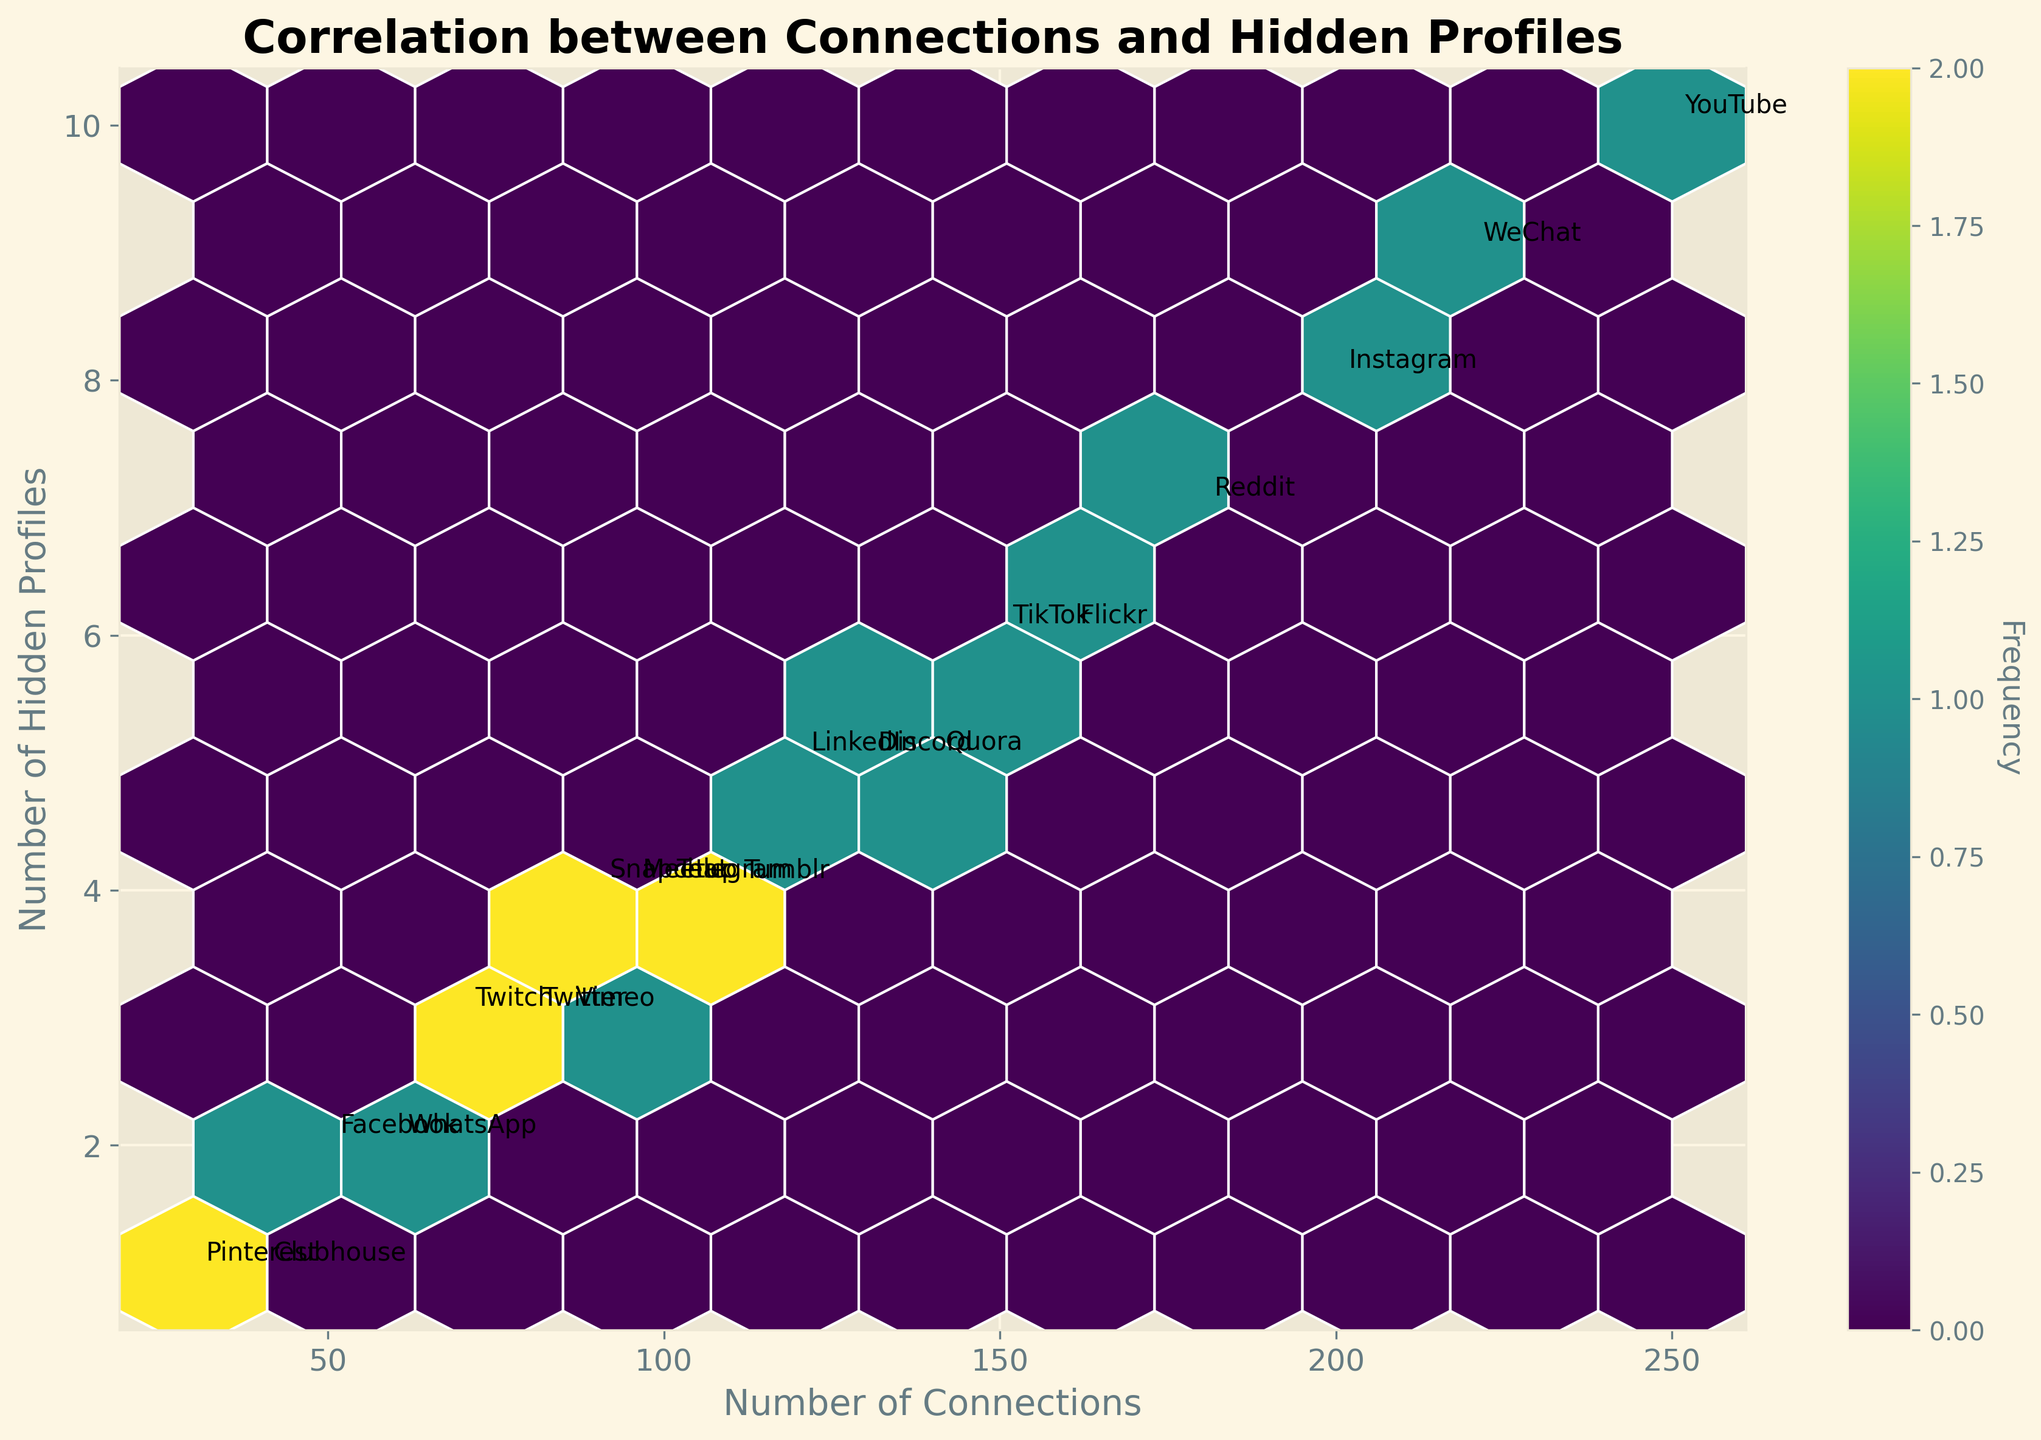what is the title of the figure? The title is typically located at the top of the figure and is meant to give an overview of what the plot depicts. In this case, it reads "Correlation between Connections and Hidden Profiles".
Answer: Correlation between Connections and Hidden Profiles What are the labels for the x and y axes? The labels for the x and y axes provide context for what the data represents. In this figure, the x-axis is labeled "Number of Connections" and the y-axis is labeled "Number of Hidden Profiles".
Answer: Number of Connections (x-axis), Number of Hidden Profiles (y-axis) How many bins with data are present in the plot? The frequency of the hexagons (bins) is depicted by color intensity and the number of bins with data can be counted visually.
Answer: 10 bins Which platform has the highest number of connections? By inspecting the annotations near the highest x-values, YouTube appears logged at the highest number of connections, 250.
Answer: YouTube Which platform has the most hidden profiles? By inspecting the annotations near the highest y-values, YouTube appears again with the highest number of hidden profiles, 10.
Answer: YouTube What’s the relationship between the number of connections and hidden profiles? Examining the color gradation and density distribution of the hexagons reveals that with more connections, hidden profiles also tend to increase, suggesting a positive correlation.
Answer: Positive correlation Which platforms appear to have similar numbers of hidden profiles? Platforms like LinkedIn, Discord, Quora, and TikTok all have 5 hidden profiles. This can be observed by their annotations aligning on the y-coordinate of 5.
Answer: LinkedIn, Discord, Quora, TikTok Which platform annotation is closest to the origin point (0,0)? The closest platform annotation to the origin (bottom-left of the figure) is Pinterest, with 30 connections and 1 hidden profile.
Answer: Pinterest Count the number of platforms that have at least 100 connections. Reviewing the annotations that have an x-value of 100 or more, the platforms are: LinkedIn, Instagram, TikTok, Reddit, Telegram, YouTube, Discord, WeChat, Tumblr, and Flickr; totaling 10.
Answer: 10 Is there a noticeable color gradient related to the density of data points? The color gradient ranging from lighter to darker colors indicates where data points are more densely populated. This can be seen particularly towards the middle range of the plot, showing higher density there.
Answer: Yes 